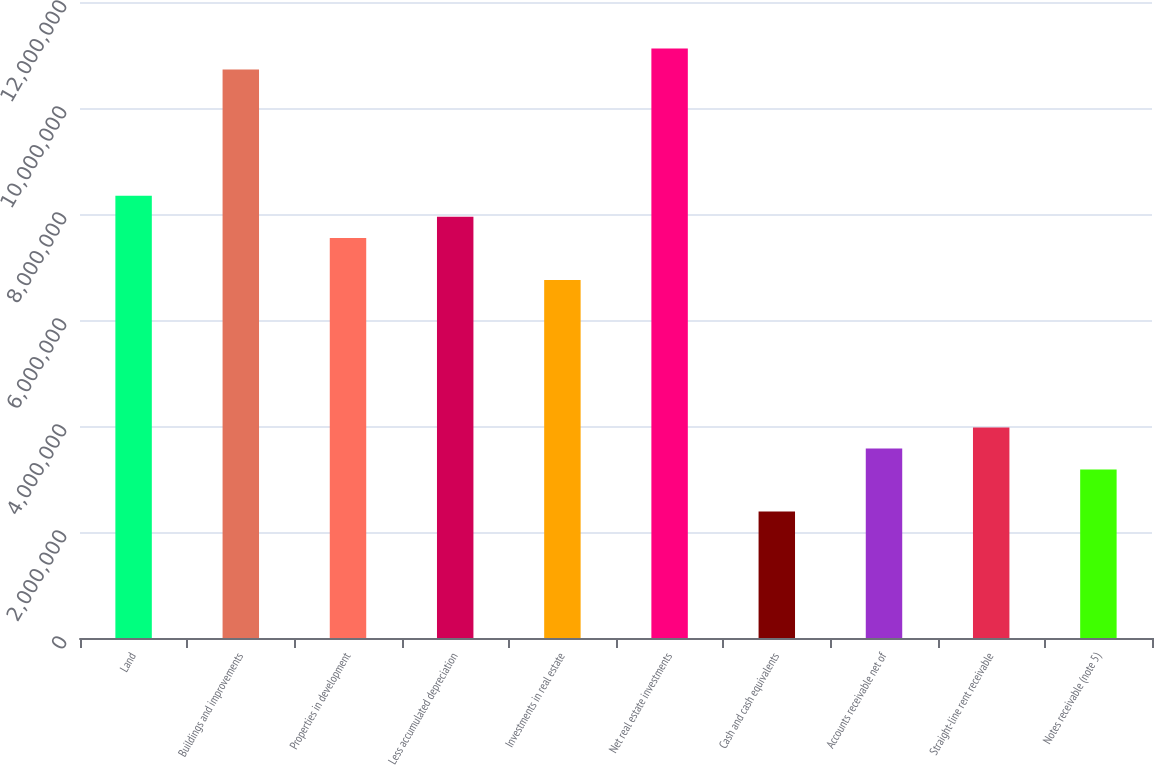<chart> <loc_0><loc_0><loc_500><loc_500><bar_chart><fcel>Land<fcel>Buildings and improvements<fcel>Properties in development<fcel>Less accumulated depreciation<fcel>Investments in real estate<fcel>Net real estate investments<fcel>Cash and cash equivalents<fcel>Accounts receivable net of<fcel>Straight-line rent receivable<fcel>Notes receivable (note 5)<nl><fcel>8.34382e+06<fcel>1.07276e+07<fcel>7.54925e+06<fcel>7.94653e+06<fcel>6.75467e+06<fcel>1.11248e+07<fcel>2.38449e+06<fcel>3.57636e+06<fcel>3.97365e+06<fcel>3.17907e+06<nl></chart> 